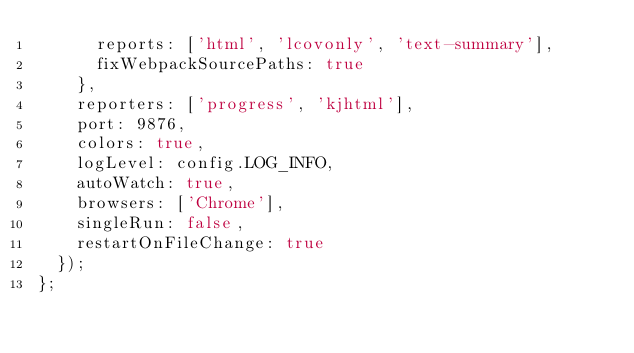<code> <loc_0><loc_0><loc_500><loc_500><_JavaScript_>      reports: ['html', 'lcovonly', 'text-summary'],
      fixWebpackSourcePaths: true
    },
    reporters: ['progress', 'kjhtml'],
    port: 9876,
    colors: true,
    logLevel: config.LOG_INFO,
    autoWatch: true,
    browsers: ['Chrome'],
    singleRun: false,
    restartOnFileChange: true
  });
};
</code> 